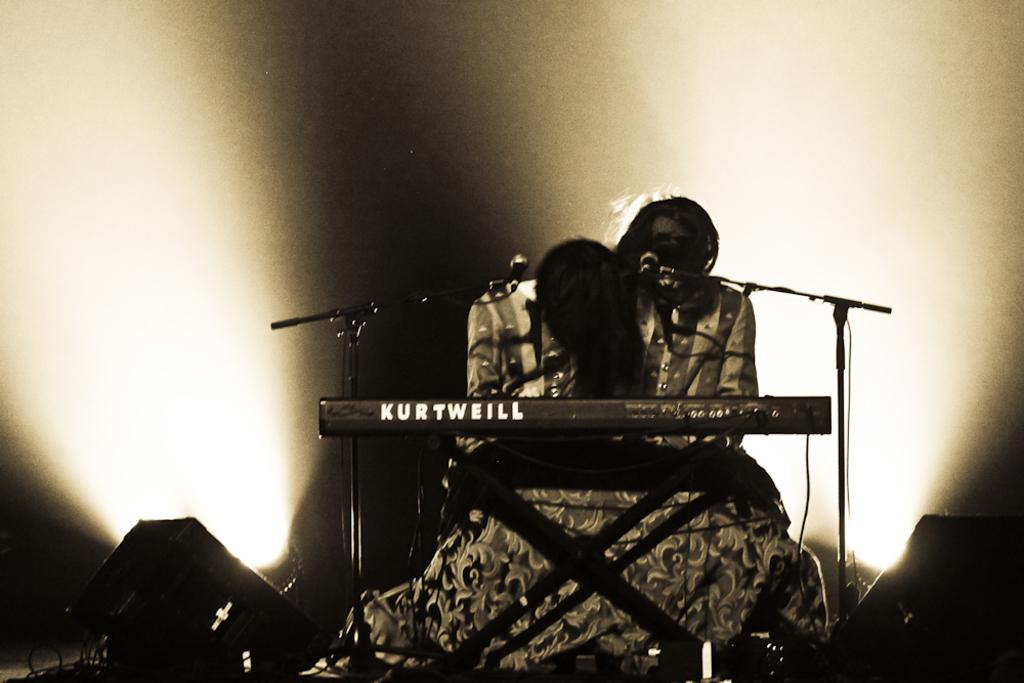How many microphones are visible in the image? There are two microphones in the image. What else can be seen in the image besides the microphones? There is a stand and a musical instrument in the image. What is the color scheme of the background in the image? The background of the image is in black and white color. What year is depicted in the image? The image does not depict a specific year; it is a still image of microphones, a stand, and a musical instrument. 